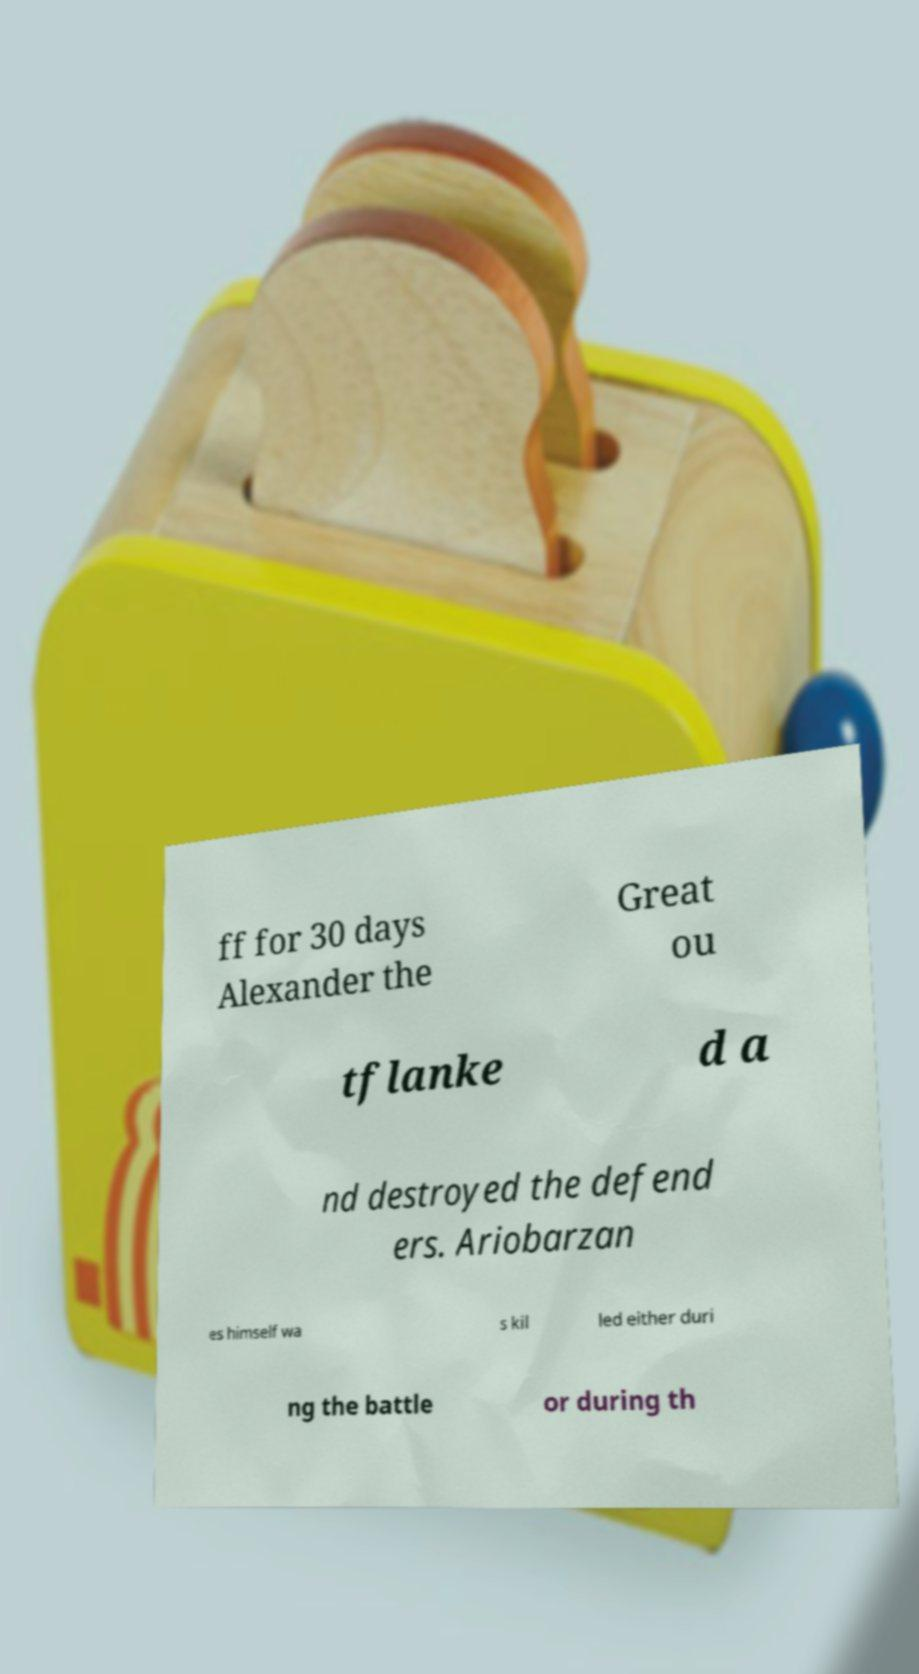What messages or text are displayed in this image? I need them in a readable, typed format. ff for 30 days Alexander the Great ou tflanke d a nd destroyed the defend ers. Ariobarzan es himself wa s kil led either duri ng the battle or during th 